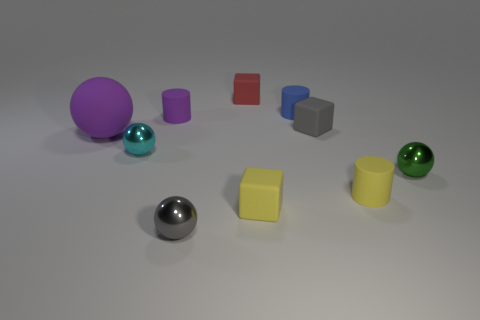Subtract all small gray cubes. How many cubes are left? 2 Subtract all cyan spheres. How many spheres are left? 3 Subtract 1 spheres. How many spheres are left? 3 Subtract all cylinders. How many objects are left? 7 Subtract all cyan cylinders. Subtract all gray cubes. How many cylinders are left? 3 Subtract all tiny gray blocks. Subtract all small cyan balls. How many objects are left? 8 Add 6 yellow matte cubes. How many yellow matte cubes are left? 7 Add 8 yellow objects. How many yellow objects exist? 10 Subtract 0 green cubes. How many objects are left? 10 